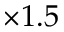<formula> <loc_0><loc_0><loc_500><loc_500>\times 1 . 5</formula> 